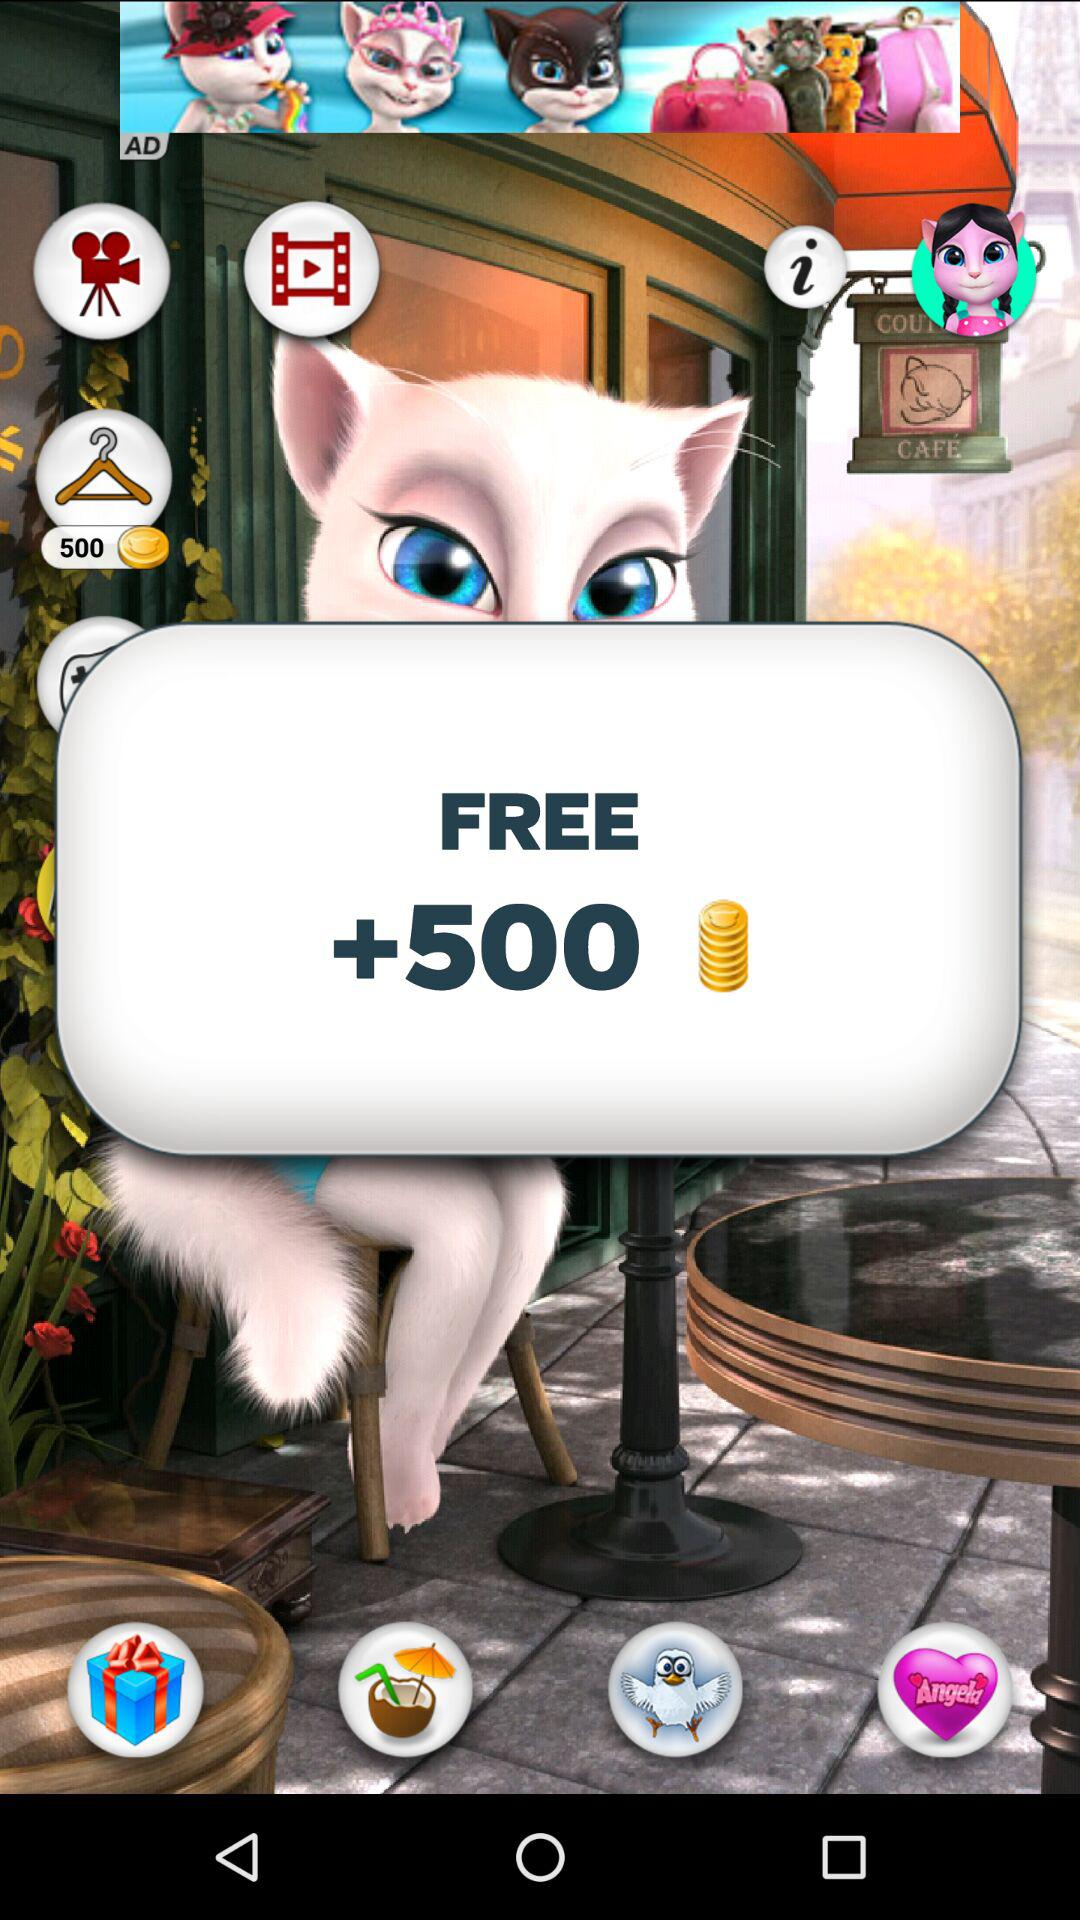How many coins are free? The number of free coins is 500. 